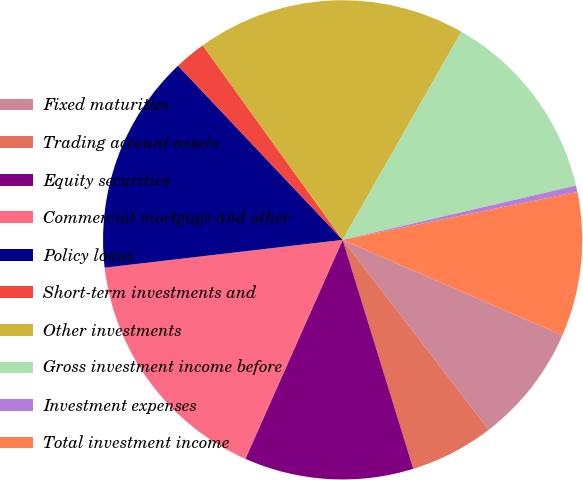<chart> <loc_0><loc_0><loc_500><loc_500><pie_chart><fcel>Fixed maturities<fcel>Trading account assets<fcel>Equity securities<fcel>Commercial mortgage and other<fcel>Policy loans<fcel>Short-term investments and<fcel>Other investments<fcel>Gross investment income before<fcel>Investment expenses<fcel>Total investment income<nl><fcel>8.04%<fcel>5.67%<fcel>11.42%<fcel>16.49%<fcel>14.8%<fcel>2.12%<fcel>18.18%<fcel>13.11%<fcel>0.43%<fcel>9.73%<nl></chart> 